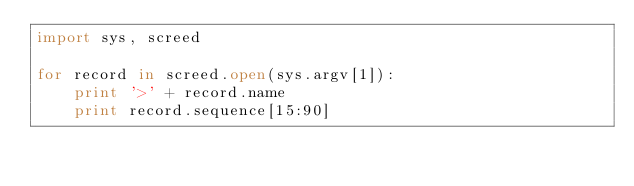Convert code to text. <code><loc_0><loc_0><loc_500><loc_500><_Python_>import sys, screed

for record in screed.open(sys.argv[1]):
    print '>' + record.name
    print record.sequence[15:90]
</code> 